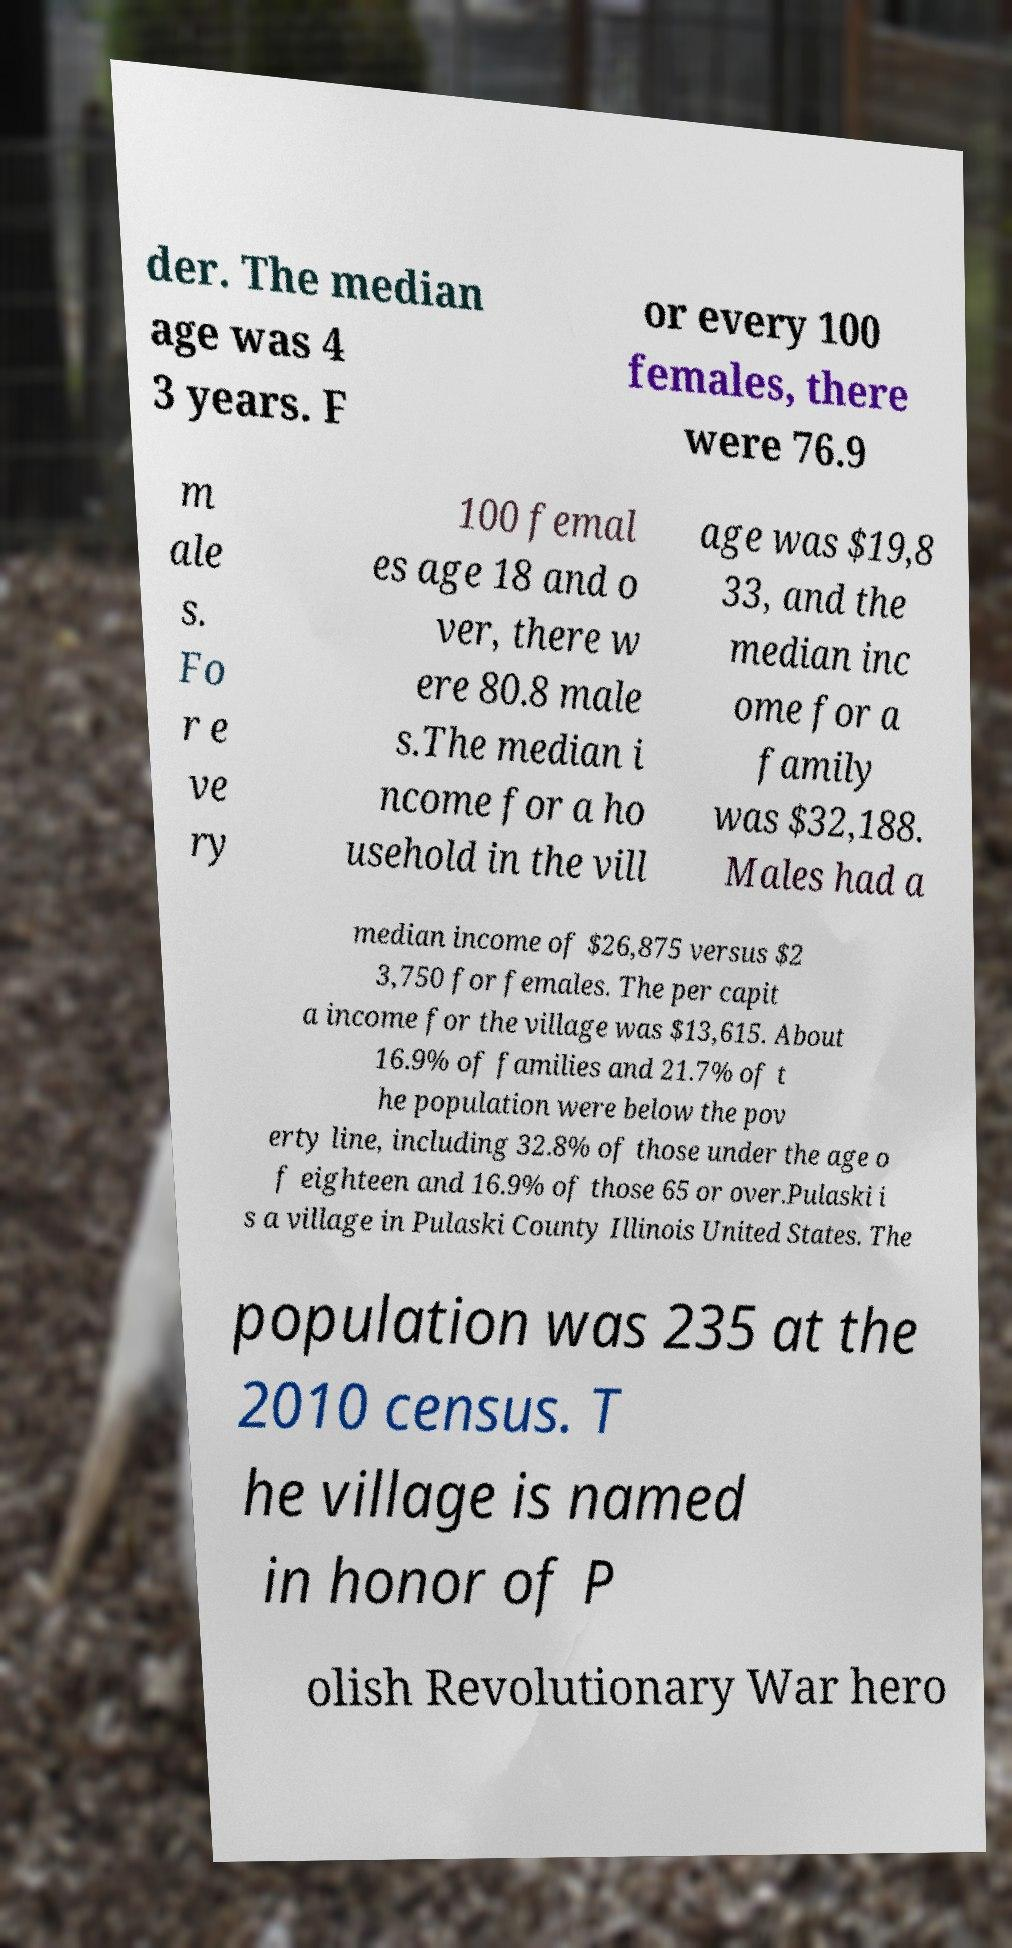Could you extract and type out the text from this image? der. The median age was 4 3 years. F or every 100 females, there were 76.9 m ale s. Fo r e ve ry 100 femal es age 18 and o ver, there w ere 80.8 male s.The median i ncome for a ho usehold in the vill age was $19,8 33, and the median inc ome for a family was $32,188. Males had a median income of $26,875 versus $2 3,750 for females. The per capit a income for the village was $13,615. About 16.9% of families and 21.7% of t he population were below the pov erty line, including 32.8% of those under the age o f eighteen and 16.9% of those 65 or over.Pulaski i s a village in Pulaski County Illinois United States. The population was 235 at the 2010 census. T he village is named in honor of P olish Revolutionary War hero 